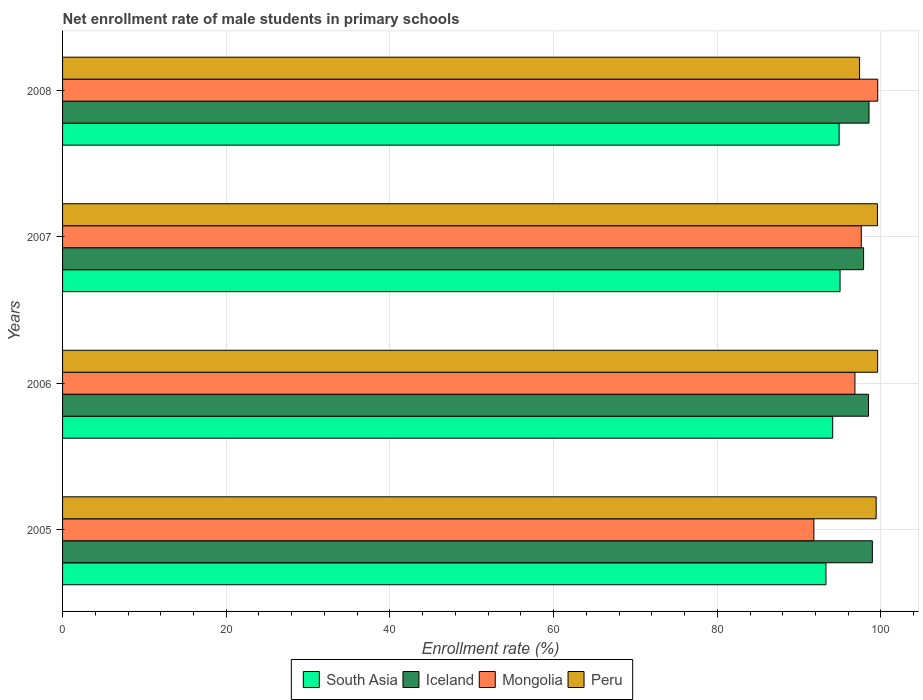What is the net enrollment rate of male students in primary schools in Iceland in 2007?
Provide a succinct answer. 97.88. Across all years, what is the maximum net enrollment rate of male students in primary schools in Mongolia?
Your answer should be very brief. 99.61. Across all years, what is the minimum net enrollment rate of male students in primary schools in Peru?
Provide a short and direct response. 97.39. In which year was the net enrollment rate of male students in primary schools in Peru maximum?
Keep it short and to the point. 2006. What is the total net enrollment rate of male students in primary schools in Peru in the graph?
Keep it short and to the point. 395.97. What is the difference between the net enrollment rate of male students in primary schools in Iceland in 2006 and that in 2007?
Your answer should be compact. 0.6. What is the difference between the net enrollment rate of male students in primary schools in South Asia in 2006 and the net enrollment rate of male students in primary schools in Peru in 2005?
Give a very brief answer. -5.31. What is the average net enrollment rate of male students in primary schools in South Asia per year?
Your answer should be very brief. 94.32. In the year 2008, what is the difference between the net enrollment rate of male students in primary schools in South Asia and net enrollment rate of male students in primary schools in Iceland?
Make the answer very short. -3.66. What is the ratio of the net enrollment rate of male students in primary schools in Iceland in 2005 to that in 2006?
Provide a succinct answer. 1. What is the difference between the highest and the second highest net enrollment rate of male students in primary schools in Mongolia?
Offer a terse response. 2.01. What is the difference between the highest and the lowest net enrollment rate of male students in primary schools in Mongolia?
Offer a terse response. 7.8. In how many years, is the net enrollment rate of male students in primary schools in South Asia greater than the average net enrollment rate of male students in primary schools in South Asia taken over all years?
Your response must be concise. 2. What does the 2nd bar from the top in 2007 represents?
Keep it short and to the point. Mongolia. What does the 3rd bar from the bottom in 2006 represents?
Ensure brevity in your answer.  Mongolia. Is it the case that in every year, the sum of the net enrollment rate of male students in primary schools in Mongolia and net enrollment rate of male students in primary schools in Iceland is greater than the net enrollment rate of male students in primary schools in South Asia?
Keep it short and to the point. Yes. How many bars are there?
Provide a short and direct response. 16. Are all the bars in the graph horizontal?
Make the answer very short. Yes. What is the difference between two consecutive major ticks on the X-axis?
Your answer should be compact. 20. Does the graph contain grids?
Offer a terse response. Yes. What is the title of the graph?
Provide a succinct answer. Net enrollment rate of male students in primary schools. What is the label or title of the X-axis?
Provide a short and direct response. Enrollment rate (%). What is the Enrollment rate (%) of South Asia in 2005?
Your answer should be compact. 93.28. What is the Enrollment rate (%) of Iceland in 2005?
Provide a short and direct response. 98.95. What is the Enrollment rate (%) of Mongolia in 2005?
Your answer should be very brief. 91.81. What is the Enrollment rate (%) in Peru in 2005?
Provide a succinct answer. 99.41. What is the Enrollment rate (%) of South Asia in 2006?
Your response must be concise. 94.1. What is the Enrollment rate (%) of Iceland in 2006?
Offer a terse response. 98.48. What is the Enrollment rate (%) of Mongolia in 2006?
Your answer should be compact. 96.82. What is the Enrollment rate (%) of Peru in 2006?
Your answer should be compact. 99.59. What is the Enrollment rate (%) of South Asia in 2007?
Your response must be concise. 95. What is the Enrollment rate (%) in Iceland in 2007?
Offer a very short reply. 97.88. What is the Enrollment rate (%) of Mongolia in 2007?
Keep it short and to the point. 97.6. What is the Enrollment rate (%) in Peru in 2007?
Provide a short and direct response. 99.57. What is the Enrollment rate (%) in South Asia in 2008?
Offer a terse response. 94.89. What is the Enrollment rate (%) in Iceland in 2008?
Your answer should be compact. 98.54. What is the Enrollment rate (%) of Mongolia in 2008?
Offer a terse response. 99.61. What is the Enrollment rate (%) in Peru in 2008?
Keep it short and to the point. 97.39. Across all years, what is the maximum Enrollment rate (%) in South Asia?
Make the answer very short. 95. Across all years, what is the maximum Enrollment rate (%) in Iceland?
Offer a very short reply. 98.95. Across all years, what is the maximum Enrollment rate (%) of Mongolia?
Make the answer very short. 99.61. Across all years, what is the maximum Enrollment rate (%) of Peru?
Your response must be concise. 99.59. Across all years, what is the minimum Enrollment rate (%) in South Asia?
Offer a very short reply. 93.28. Across all years, what is the minimum Enrollment rate (%) of Iceland?
Provide a short and direct response. 97.88. Across all years, what is the minimum Enrollment rate (%) in Mongolia?
Provide a short and direct response. 91.81. Across all years, what is the minimum Enrollment rate (%) in Peru?
Provide a succinct answer. 97.39. What is the total Enrollment rate (%) in South Asia in the graph?
Offer a very short reply. 377.28. What is the total Enrollment rate (%) of Iceland in the graph?
Keep it short and to the point. 393.86. What is the total Enrollment rate (%) in Mongolia in the graph?
Give a very brief answer. 385.83. What is the total Enrollment rate (%) of Peru in the graph?
Your response must be concise. 395.97. What is the difference between the Enrollment rate (%) in South Asia in 2005 and that in 2006?
Provide a succinct answer. -0.82. What is the difference between the Enrollment rate (%) in Iceland in 2005 and that in 2006?
Offer a very short reply. 0.47. What is the difference between the Enrollment rate (%) in Mongolia in 2005 and that in 2006?
Ensure brevity in your answer.  -5.01. What is the difference between the Enrollment rate (%) of Peru in 2005 and that in 2006?
Make the answer very short. -0.18. What is the difference between the Enrollment rate (%) in South Asia in 2005 and that in 2007?
Make the answer very short. -1.72. What is the difference between the Enrollment rate (%) of Iceland in 2005 and that in 2007?
Give a very brief answer. 1.07. What is the difference between the Enrollment rate (%) of Mongolia in 2005 and that in 2007?
Offer a terse response. -5.79. What is the difference between the Enrollment rate (%) of Peru in 2005 and that in 2007?
Your answer should be very brief. -0.16. What is the difference between the Enrollment rate (%) of South Asia in 2005 and that in 2008?
Provide a short and direct response. -1.61. What is the difference between the Enrollment rate (%) in Iceland in 2005 and that in 2008?
Make the answer very short. 0.4. What is the difference between the Enrollment rate (%) of Mongolia in 2005 and that in 2008?
Provide a short and direct response. -7.8. What is the difference between the Enrollment rate (%) in Peru in 2005 and that in 2008?
Provide a short and direct response. 2.03. What is the difference between the Enrollment rate (%) of South Asia in 2006 and that in 2007?
Provide a succinct answer. -0.9. What is the difference between the Enrollment rate (%) in Iceland in 2006 and that in 2007?
Give a very brief answer. 0.6. What is the difference between the Enrollment rate (%) in Mongolia in 2006 and that in 2007?
Ensure brevity in your answer.  -0.78. What is the difference between the Enrollment rate (%) in Peru in 2006 and that in 2007?
Ensure brevity in your answer.  0.02. What is the difference between the Enrollment rate (%) of South Asia in 2006 and that in 2008?
Your answer should be compact. -0.79. What is the difference between the Enrollment rate (%) of Iceland in 2006 and that in 2008?
Offer a terse response. -0.06. What is the difference between the Enrollment rate (%) in Mongolia in 2006 and that in 2008?
Offer a very short reply. -2.79. What is the difference between the Enrollment rate (%) of Peru in 2006 and that in 2008?
Make the answer very short. 2.21. What is the difference between the Enrollment rate (%) of South Asia in 2007 and that in 2008?
Ensure brevity in your answer.  0.11. What is the difference between the Enrollment rate (%) of Iceland in 2007 and that in 2008?
Offer a terse response. -0.66. What is the difference between the Enrollment rate (%) of Mongolia in 2007 and that in 2008?
Provide a succinct answer. -2.01. What is the difference between the Enrollment rate (%) of Peru in 2007 and that in 2008?
Your answer should be very brief. 2.18. What is the difference between the Enrollment rate (%) in South Asia in 2005 and the Enrollment rate (%) in Iceland in 2006?
Make the answer very short. -5.2. What is the difference between the Enrollment rate (%) in South Asia in 2005 and the Enrollment rate (%) in Mongolia in 2006?
Make the answer very short. -3.54. What is the difference between the Enrollment rate (%) in South Asia in 2005 and the Enrollment rate (%) in Peru in 2006?
Make the answer very short. -6.31. What is the difference between the Enrollment rate (%) of Iceland in 2005 and the Enrollment rate (%) of Mongolia in 2006?
Provide a succinct answer. 2.13. What is the difference between the Enrollment rate (%) in Iceland in 2005 and the Enrollment rate (%) in Peru in 2006?
Ensure brevity in your answer.  -0.65. What is the difference between the Enrollment rate (%) in Mongolia in 2005 and the Enrollment rate (%) in Peru in 2006?
Give a very brief answer. -7.79. What is the difference between the Enrollment rate (%) of South Asia in 2005 and the Enrollment rate (%) of Iceland in 2007?
Make the answer very short. -4.6. What is the difference between the Enrollment rate (%) of South Asia in 2005 and the Enrollment rate (%) of Mongolia in 2007?
Your response must be concise. -4.32. What is the difference between the Enrollment rate (%) in South Asia in 2005 and the Enrollment rate (%) in Peru in 2007?
Ensure brevity in your answer.  -6.29. What is the difference between the Enrollment rate (%) of Iceland in 2005 and the Enrollment rate (%) of Mongolia in 2007?
Provide a succinct answer. 1.35. What is the difference between the Enrollment rate (%) of Iceland in 2005 and the Enrollment rate (%) of Peru in 2007?
Make the answer very short. -0.62. What is the difference between the Enrollment rate (%) in Mongolia in 2005 and the Enrollment rate (%) in Peru in 2007?
Keep it short and to the point. -7.77. What is the difference between the Enrollment rate (%) of South Asia in 2005 and the Enrollment rate (%) of Iceland in 2008?
Keep it short and to the point. -5.26. What is the difference between the Enrollment rate (%) of South Asia in 2005 and the Enrollment rate (%) of Mongolia in 2008?
Keep it short and to the point. -6.33. What is the difference between the Enrollment rate (%) in South Asia in 2005 and the Enrollment rate (%) in Peru in 2008?
Provide a short and direct response. -4.11. What is the difference between the Enrollment rate (%) of Iceland in 2005 and the Enrollment rate (%) of Mongolia in 2008?
Keep it short and to the point. -0.66. What is the difference between the Enrollment rate (%) in Iceland in 2005 and the Enrollment rate (%) in Peru in 2008?
Provide a short and direct response. 1.56. What is the difference between the Enrollment rate (%) of Mongolia in 2005 and the Enrollment rate (%) of Peru in 2008?
Your answer should be very brief. -5.58. What is the difference between the Enrollment rate (%) in South Asia in 2006 and the Enrollment rate (%) in Iceland in 2007?
Provide a succinct answer. -3.78. What is the difference between the Enrollment rate (%) in South Asia in 2006 and the Enrollment rate (%) in Mongolia in 2007?
Your response must be concise. -3.49. What is the difference between the Enrollment rate (%) of South Asia in 2006 and the Enrollment rate (%) of Peru in 2007?
Ensure brevity in your answer.  -5.47. What is the difference between the Enrollment rate (%) of Iceland in 2006 and the Enrollment rate (%) of Mongolia in 2007?
Give a very brief answer. 0.88. What is the difference between the Enrollment rate (%) in Iceland in 2006 and the Enrollment rate (%) in Peru in 2007?
Ensure brevity in your answer.  -1.09. What is the difference between the Enrollment rate (%) in Mongolia in 2006 and the Enrollment rate (%) in Peru in 2007?
Provide a short and direct response. -2.75. What is the difference between the Enrollment rate (%) in South Asia in 2006 and the Enrollment rate (%) in Iceland in 2008?
Your answer should be compact. -4.44. What is the difference between the Enrollment rate (%) of South Asia in 2006 and the Enrollment rate (%) of Mongolia in 2008?
Make the answer very short. -5.5. What is the difference between the Enrollment rate (%) of South Asia in 2006 and the Enrollment rate (%) of Peru in 2008?
Give a very brief answer. -3.29. What is the difference between the Enrollment rate (%) in Iceland in 2006 and the Enrollment rate (%) in Mongolia in 2008?
Your response must be concise. -1.13. What is the difference between the Enrollment rate (%) in Iceland in 2006 and the Enrollment rate (%) in Peru in 2008?
Provide a short and direct response. 1.09. What is the difference between the Enrollment rate (%) in Mongolia in 2006 and the Enrollment rate (%) in Peru in 2008?
Your answer should be compact. -0.57. What is the difference between the Enrollment rate (%) of South Asia in 2007 and the Enrollment rate (%) of Iceland in 2008?
Offer a very short reply. -3.54. What is the difference between the Enrollment rate (%) in South Asia in 2007 and the Enrollment rate (%) in Mongolia in 2008?
Your answer should be very brief. -4.6. What is the difference between the Enrollment rate (%) of South Asia in 2007 and the Enrollment rate (%) of Peru in 2008?
Your response must be concise. -2.39. What is the difference between the Enrollment rate (%) in Iceland in 2007 and the Enrollment rate (%) in Mongolia in 2008?
Offer a terse response. -1.73. What is the difference between the Enrollment rate (%) of Iceland in 2007 and the Enrollment rate (%) of Peru in 2008?
Give a very brief answer. 0.49. What is the difference between the Enrollment rate (%) of Mongolia in 2007 and the Enrollment rate (%) of Peru in 2008?
Your answer should be very brief. 0.21. What is the average Enrollment rate (%) in South Asia per year?
Keep it short and to the point. 94.32. What is the average Enrollment rate (%) of Iceland per year?
Make the answer very short. 98.46. What is the average Enrollment rate (%) in Mongolia per year?
Make the answer very short. 96.46. What is the average Enrollment rate (%) in Peru per year?
Give a very brief answer. 98.99. In the year 2005, what is the difference between the Enrollment rate (%) of South Asia and Enrollment rate (%) of Iceland?
Your answer should be very brief. -5.67. In the year 2005, what is the difference between the Enrollment rate (%) of South Asia and Enrollment rate (%) of Mongolia?
Offer a very short reply. 1.48. In the year 2005, what is the difference between the Enrollment rate (%) in South Asia and Enrollment rate (%) in Peru?
Keep it short and to the point. -6.13. In the year 2005, what is the difference between the Enrollment rate (%) of Iceland and Enrollment rate (%) of Mongolia?
Your response must be concise. 7.14. In the year 2005, what is the difference between the Enrollment rate (%) in Iceland and Enrollment rate (%) in Peru?
Give a very brief answer. -0.47. In the year 2005, what is the difference between the Enrollment rate (%) of Mongolia and Enrollment rate (%) of Peru?
Ensure brevity in your answer.  -7.61. In the year 2006, what is the difference between the Enrollment rate (%) in South Asia and Enrollment rate (%) in Iceland?
Your answer should be compact. -4.38. In the year 2006, what is the difference between the Enrollment rate (%) in South Asia and Enrollment rate (%) in Mongolia?
Keep it short and to the point. -2.72. In the year 2006, what is the difference between the Enrollment rate (%) in South Asia and Enrollment rate (%) in Peru?
Provide a succinct answer. -5.49. In the year 2006, what is the difference between the Enrollment rate (%) of Iceland and Enrollment rate (%) of Mongolia?
Ensure brevity in your answer.  1.66. In the year 2006, what is the difference between the Enrollment rate (%) of Iceland and Enrollment rate (%) of Peru?
Keep it short and to the point. -1.11. In the year 2006, what is the difference between the Enrollment rate (%) of Mongolia and Enrollment rate (%) of Peru?
Keep it short and to the point. -2.77. In the year 2007, what is the difference between the Enrollment rate (%) in South Asia and Enrollment rate (%) in Iceland?
Your response must be concise. -2.88. In the year 2007, what is the difference between the Enrollment rate (%) of South Asia and Enrollment rate (%) of Mongolia?
Keep it short and to the point. -2.59. In the year 2007, what is the difference between the Enrollment rate (%) in South Asia and Enrollment rate (%) in Peru?
Provide a succinct answer. -4.57. In the year 2007, what is the difference between the Enrollment rate (%) in Iceland and Enrollment rate (%) in Mongolia?
Your answer should be compact. 0.28. In the year 2007, what is the difference between the Enrollment rate (%) in Iceland and Enrollment rate (%) in Peru?
Keep it short and to the point. -1.69. In the year 2007, what is the difference between the Enrollment rate (%) of Mongolia and Enrollment rate (%) of Peru?
Your answer should be very brief. -1.97. In the year 2008, what is the difference between the Enrollment rate (%) of South Asia and Enrollment rate (%) of Iceland?
Make the answer very short. -3.66. In the year 2008, what is the difference between the Enrollment rate (%) of South Asia and Enrollment rate (%) of Mongolia?
Offer a very short reply. -4.72. In the year 2008, what is the difference between the Enrollment rate (%) of South Asia and Enrollment rate (%) of Peru?
Offer a very short reply. -2.5. In the year 2008, what is the difference between the Enrollment rate (%) in Iceland and Enrollment rate (%) in Mongolia?
Provide a short and direct response. -1.06. In the year 2008, what is the difference between the Enrollment rate (%) in Iceland and Enrollment rate (%) in Peru?
Give a very brief answer. 1.16. In the year 2008, what is the difference between the Enrollment rate (%) in Mongolia and Enrollment rate (%) in Peru?
Provide a short and direct response. 2.22. What is the ratio of the Enrollment rate (%) in Iceland in 2005 to that in 2006?
Provide a succinct answer. 1. What is the ratio of the Enrollment rate (%) of Mongolia in 2005 to that in 2006?
Your answer should be very brief. 0.95. What is the ratio of the Enrollment rate (%) in Peru in 2005 to that in 2006?
Provide a short and direct response. 1. What is the ratio of the Enrollment rate (%) in South Asia in 2005 to that in 2007?
Make the answer very short. 0.98. What is the ratio of the Enrollment rate (%) in Iceland in 2005 to that in 2007?
Make the answer very short. 1.01. What is the ratio of the Enrollment rate (%) in Mongolia in 2005 to that in 2007?
Give a very brief answer. 0.94. What is the ratio of the Enrollment rate (%) of Mongolia in 2005 to that in 2008?
Make the answer very short. 0.92. What is the ratio of the Enrollment rate (%) of Peru in 2005 to that in 2008?
Offer a very short reply. 1.02. What is the ratio of the Enrollment rate (%) of South Asia in 2006 to that in 2008?
Your answer should be very brief. 0.99. What is the ratio of the Enrollment rate (%) of Iceland in 2006 to that in 2008?
Your answer should be very brief. 1. What is the ratio of the Enrollment rate (%) in Peru in 2006 to that in 2008?
Give a very brief answer. 1.02. What is the ratio of the Enrollment rate (%) in South Asia in 2007 to that in 2008?
Ensure brevity in your answer.  1. What is the ratio of the Enrollment rate (%) of Iceland in 2007 to that in 2008?
Provide a succinct answer. 0.99. What is the ratio of the Enrollment rate (%) of Mongolia in 2007 to that in 2008?
Make the answer very short. 0.98. What is the ratio of the Enrollment rate (%) in Peru in 2007 to that in 2008?
Your answer should be very brief. 1.02. What is the difference between the highest and the second highest Enrollment rate (%) in South Asia?
Ensure brevity in your answer.  0.11. What is the difference between the highest and the second highest Enrollment rate (%) of Iceland?
Offer a very short reply. 0.4. What is the difference between the highest and the second highest Enrollment rate (%) in Mongolia?
Provide a succinct answer. 2.01. What is the difference between the highest and the second highest Enrollment rate (%) in Peru?
Ensure brevity in your answer.  0.02. What is the difference between the highest and the lowest Enrollment rate (%) in South Asia?
Offer a very short reply. 1.72. What is the difference between the highest and the lowest Enrollment rate (%) of Iceland?
Ensure brevity in your answer.  1.07. What is the difference between the highest and the lowest Enrollment rate (%) in Mongolia?
Your answer should be very brief. 7.8. What is the difference between the highest and the lowest Enrollment rate (%) in Peru?
Make the answer very short. 2.21. 